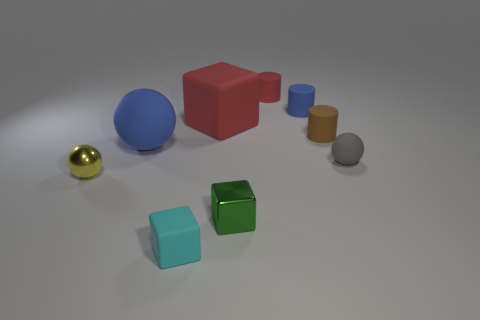Add 1 tiny green matte things. How many objects exist? 10 Subtract all blocks. How many objects are left? 6 Subtract 0 brown balls. How many objects are left? 9 Subtract all small yellow spheres. Subtract all tiny red things. How many objects are left? 7 Add 5 brown matte things. How many brown matte things are left? 6 Add 5 large matte spheres. How many large matte spheres exist? 6 